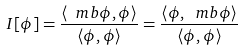<formula> <loc_0><loc_0><loc_500><loc_500>I [ \phi ] = \frac { \left < \ m b \phi , \phi \right > } { \left < \phi , \phi \right > } = \frac { \left < \phi , \ m b \phi \right > } { \left < \phi , \phi \right > }</formula> 